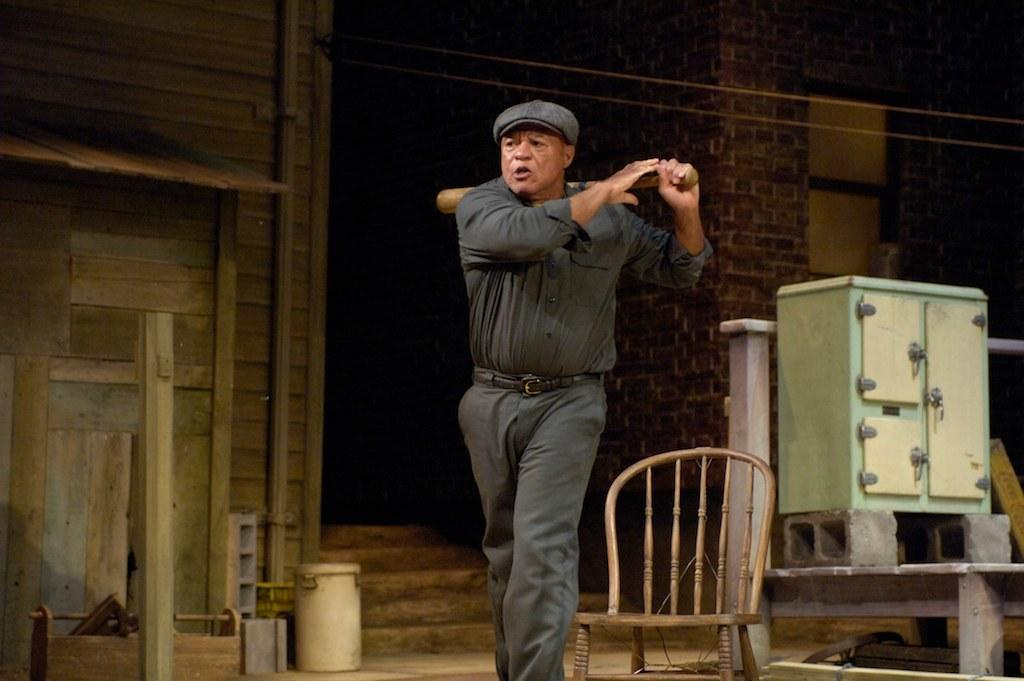What is the man in the image doing? The man is standing in the image and holding a bat in his hand. What can be seen in the background of the image? There is a wall, a chair, and a window in the background of the image. What type of ring is the man wearing on his finger in the image? There is no ring visible on the man's finger in the image. 